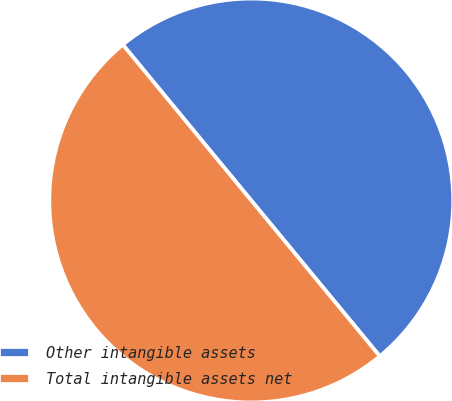Convert chart to OTSL. <chart><loc_0><loc_0><loc_500><loc_500><pie_chart><fcel>Other intangible assets<fcel>Total intangible assets net<nl><fcel>49.99%<fcel>50.01%<nl></chart> 